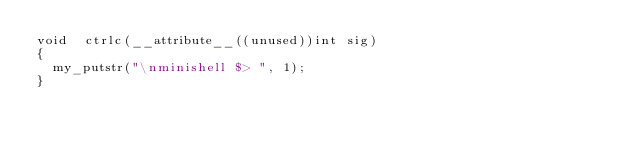Convert code to text. <code><loc_0><loc_0><loc_500><loc_500><_C_>void	ctrlc(__attribute__((unused))int sig)
{
  my_putstr("\nminishell $> ", 1);
}
</code> 